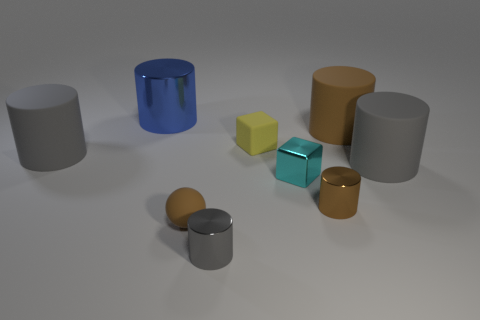Add 1 tiny gray cylinders. How many objects exist? 10 Subtract all big brown cylinders. How many cylinders are left? 5 Subtract all brown cylinders. How many cylinders are left? 4 Subtract 6 cylinders. How many cylinders are left? 0 Subtract all blue cylinders. Subtract all cyan spheres. How many cylinders are left? 5 Subtract all brown blocks. How many gray cylinders are left? 3 Subtract all large rubber things. Subtract all rubber objects. How many objects are left? 1 Add 5 brown rubber balls. How many brown rubber balls are left? 6 Add 9 large cyan metal balls. How many large cyan metal balls exist? 9 Subtract 1 cyan blocks. How many objects are left? 8 